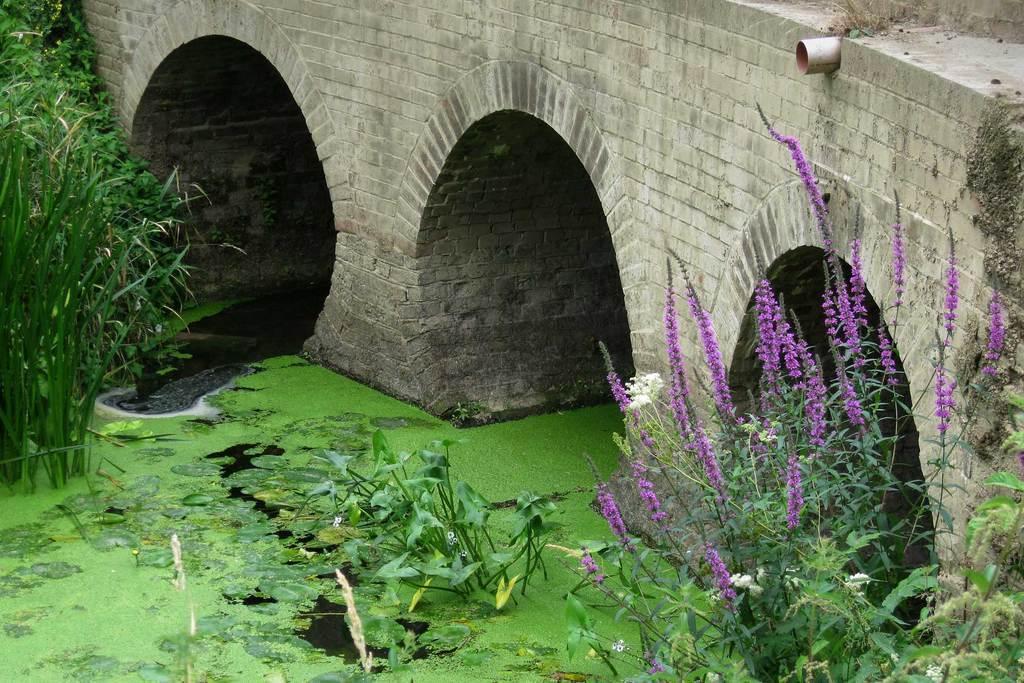Can you describe this image briefly? At the bottom I can see the water. On the water there is green algae and there are some plants along with the flowers. At the top of the image there is a bridge. 